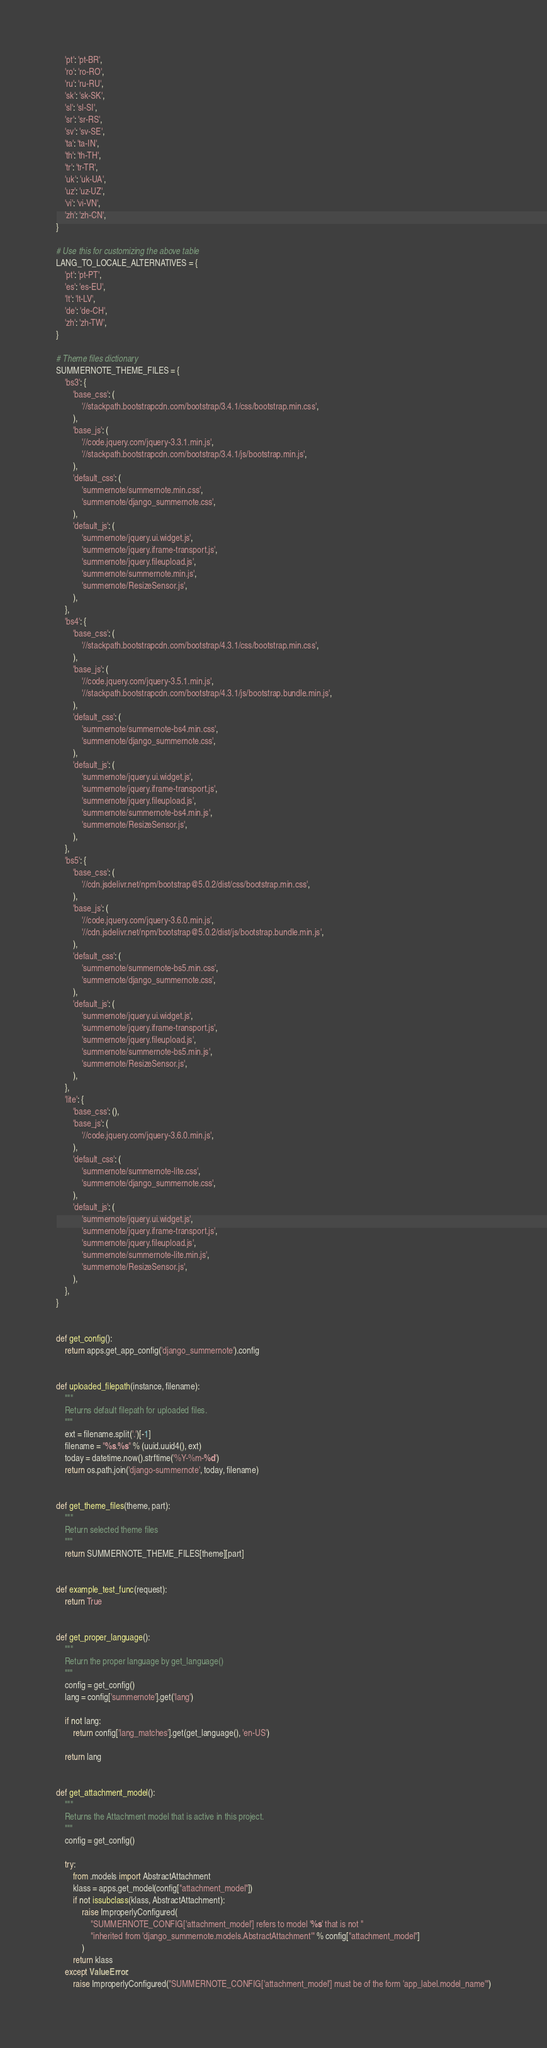Convert code to text. <code><loc_0><loc_0><loc_500><loc_500><_Python_>    'pt': 'pt-BR',
    'ro': 'ro-RO',
    'ru': 'ru-RU',
    'sk': 'sk-SK',
    'sl': 'sl-SI',
    'sr': 'sr-RS',
    'sv': 'sv-SE',
    'ta': 'ta-IN',
    'th': 'th-TH',
    'tr': 'tr-TR',
    'uk': 'uk-UA',
    'uz': 'uz-UZ',
    'vi': 'vi-VN',
    'zh': 'zh-CN',
}

# Use this for customizing the above table
LANG_TO_LOCALE_ALTERNATIVES = {
    'pt': 'pt-PT',
    'es': 'es-EU',
    'lt': 'lt-LV',
    'de': 'de-CH',
    'zh': 'zh-TW',
}

# Theme files dictionary
SUMMERNOTE_THEME_FILES = {
    'bs3': {
        'base_css': (
            '//stackpath.bootstrapcdn.com/bootstrap/3.4.1/css/bootstrap.min.css',
        ),
        'base_js': (
            '//code.jquery.com/jquery-3.3.1.min.js',
            '//stackpath.bootstrapcdn.com/bootstrap/3.4.1/js/bootstrap.min.js',
        ),
        'default_css': (
            'summernote/summernote.min.css',
            'summernote/django_summernote.css',
        ),
        'default_js': (
            'summernote/jquery.ui.widget.js',
            'summernote/jquery.iframe-transport.js',
            'summernote/jquery.fileupload.js',
            'summernote/summernote.min.js',
            'summernote/ResizeSensor.js',
        ),
    },
    'bs4': {
        'base_css': (
            '//stackpath.bootstrapcdn.com/bootstrap/4.3.1/css/bootstrap.min.css',
        ),
        'base_js': (
            '//code.jquery.com/jquery-3.5.1.min.js',
            '//stackpath.bootstrapcdn.com/bootstrap/4.3.1/js/bootstrap.bundle.min.js',
        ),
        'default_css': (
            'summernote/summernote-bs4.min.css',
            'summernote/django_summernote.css',
        ),
        'default_js': (
            'summernote/jquery.ui.widget.js',
            'summernote/jquery.iframe-transport.js',
            'summernote/jquery.fileupload.js',
            'summernote/summernote-bs4.min.js',
            'summernote/ResizeSensor.js',
        ),
    },
    'bs5': {
        'base_css': (
            '//cdn.jsdelivr.net/npm/bootstrap@5.0.2/dist/css/bootstrap.min.css',
        ),
        'base_js': (
            '//code.jquery.com/jquery-3.6.0.min.js',
            '//cdn.jsdelivr.net/npm/bootstrap@5.0.2/dist/js/bootstrap.bundle.min.js',
        ),
        'default_css': (
            'summernote/summernote-bs5.min.css',
            'summernote/django_summernote.css',
        ),
        'default_js': (
            'summernote/jquery.ui.widget.js',
            'summernote/jquery.iframe-transport.js',
            'summernote/jquery.fileupload.js',
            'summernote/summernote-bs5.min.js',
            'summernote/ResizeSensor.js',
        ),
    },
    'lite': {
        'base_css': (),
        'base_js': (
            '//code.jquery.com/jquery-3.6.0.min.js',
        ),
        'default_css': (
            'summernote/summernote-lite.css',
            'summernote/django_summernote.css',
        ),
        'default_js': (
            'summernote/jquery.ui.widget.js',
            'summernote/jquery.iframe-transport.js',
            'summernote/jquery.fileupload.js',
            'summernote/summernote-lite.min.js',
            'summernote/ResizeSensor.js',
        ),
    },
}


def get_config():
    return apps.get_app_config('django_summernote').config


def uploaded_filepath(instance, filename):
    """
    Returns default filepath for uploaded files.
    """
    ext = filename.split('.')[-1]
    filename = "%s.%s" % (uuid.uuid4(), ext)
    today = datetime.now().strftime('%Y-%m-%d')
    return os.path.join('django-summernote', today, filename)


def get_theme_files(theme, part):
    """
    Return selected theme files
    """
    return SUMMERNOTE_THEME_FILES[theme][part]


def example_test_func(request):
    return True


def get_proper_language():
    """
    Return the proper language by get_language()
    """
    config = get_config()
    lang = config['summernote'].get('lang')

    if not lang:
        return config['lang_matches'].get(get_language(), 'en-US')

    return lang


def get_attachment_model():
    """
    Returns the Attachment model that is active in this project.
    """
    config = get_config()

    try:
        from .models import AbstractAttachment
        klass = apps.get_model(config["attachment_model"])
        if not issubclass(klass, AbstractAttachment):
            raise ImproperlyConfigured(
                "SUMMERNOTE_CONFIG['attachment_model'] refers to model '%s' that is not "
                "inherited from 'django_summernote.models.AbstractAttachment'" % config["attachment_model"]
            )
        return klass
    except ValueError:
        raise ImproperlyConfigured("SUMMERNOTE_CONFIG['attachment_model'] must be of the form 'app_label.model_name'")</code> 